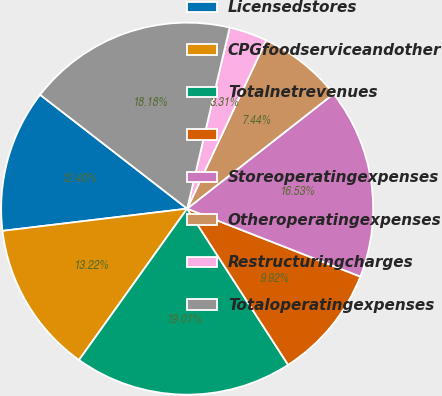Convert chart to OTSL. <chart><loc_0><loc_0><loc_500><loc_500><pie_chart><fcel>Licensedstores<fcel>CPGfoodserviceandother<fcel>Totalnetrevenues<fcel>Unnamed: 3<fcel>Storeoperatingexpenses<fcel>Otheroperatingexpenses<fcel>Restructuringcharges<fcel>Totaloperatingexpenses<nl><fcel>12.4%<fcel>13.22%<fcel>19.01%<fcel>9.92%<fcel>16.53%<fcel>7.44%<fcel>3.31%<fcel>18.18%<nl></chart> 